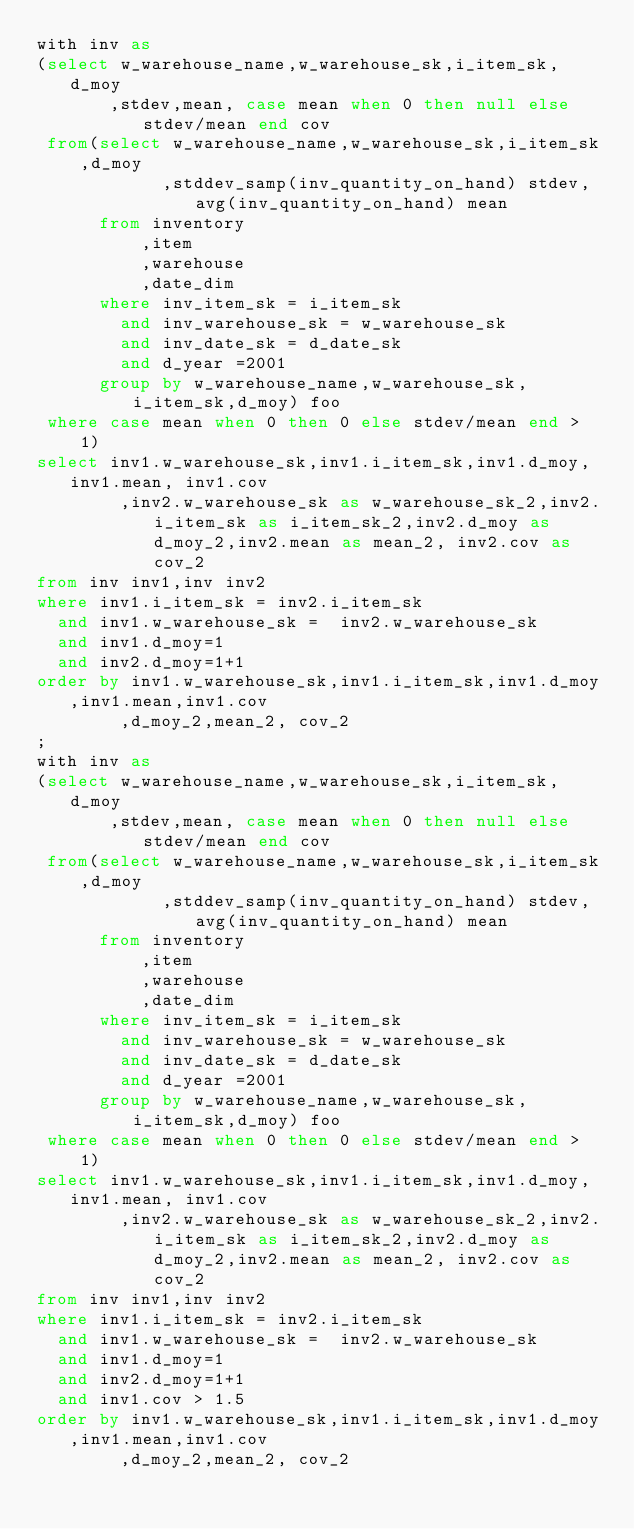Convert code to text. <code><loc_0><loc_0><loc_500><loc_500><_SQL_>with inv as
(select w_warehouse_name,w_warehouse_sk,i_item_sk,d_moy
       ,stdev,mean, case mean when 0 then null else stdev/mean end cov
 from(select w_warehouse_name,w_warehouse_sk,i_item_sk,d_moy
            ,stddev_samp(inv_quantity_on_hand) stdev,avg(inv_quantity_on_hand) mean
      from inventory
          ,item
          ,warehouse
          ,date_dim
      where inv_item_sk = i_item_sk
        and inv_warehouse_sk = w_warehouse_sk
        and inv_date_sk = d_date_sk
        and d_year =2001
      group by w_warehouse_name,w_warehouse_sk,i_item_sk,d_moy) foo
 where case mean when 0 then 0 else stdev/mean end > 1)
select inv1.w_warehouse_sk,inv1.i_item_sk,inv1.d_moy,inv1.mean, inv1.cov
        ,inv2.w_warehouse_sk as w_warehouse_sk_2,inv2.i_item_sk as i_item_sk_2,inv2.d_moy as d_moy_2,inv2.mean as mean_2, inv2.cov as cov_2
from inv inv1,inv inv2
where inv1.i_item_sk = inv2.i_item_sk
  and inv1.w_warehouse_sk =  inv2.w_warehouse_sk
  and inv1.d_moy=1
  and inv2.d_moy=1+1
order by inv1.w_warehouse_sk,inv1.i_item_sk,inv1.d_moy,inv1.mean,inv1.cov
        ,d_moy_2,mean_2, cov_2
;
with inv as
(select w_warehouse_name,w_warehouse_sk,i_item_sk,d_moy
       ,stdev,mean, case mean when 0 then null else stdev/mean end cov
 from(select w_warehouse_name,w_warehouse_sk,i_item_sk,d_moy
            ,stddev_samp(inv_quantity_on_hand) stdev,avg(inv_quantity_on_hand) mean
      from inventory
          ,item
          ,warehouse
          ,date_dim
      where inv_item_sk = i_item_sk
        and inv_warehouse_sk = w_warehouse_sk
        and inv_date_sk = d_date_sk
        and d_year =2001
      group by w_warehouse_name,w_warehouse_sk,i_item_sk,d_moy) foo
 where case mean when 0 then 0 else stdev/mean end > 1)
select inv1.w_warehouse_sk,inv1.i_item_sk,inv1.d_moy,inv1.mean, inv1.cov
        ,inv2.w_warehouse_sk as w_warehouse_sk_2,inv2.i_item_sk as i_item_sk_2,inv2.d_moy as d_moy_2,inv2.mean as mean_2, inv2.cov as cov_2
from inv inv1,inv inv2
where inv1.i_item_sk = inv2.i_item_sk
  and inv1.w_warehouse_sk =  inv2.w_warehouse_sk
  and inv1.d_moy=1
  and inv2.d_moy=1+1
  and inv1.cov > 1.5
order by inv1.w_warehouse_sk,inv1.i_item_sk,inv1.d_moy,inv1.mean,inv1.cov
        ,d_moy_2,mean_2, cov_2
</code> 